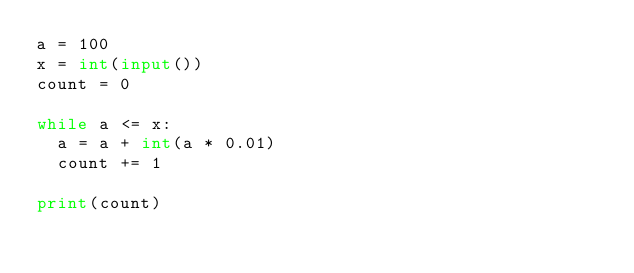Convert code to text. <code><loc_0><loc_0><loc_500><loc_500><_Python_>a = 100
x = int(input())
count = 0

while a <= x:
  a = a + int(a * 0.01)
  count += 1

print(count)</code> 